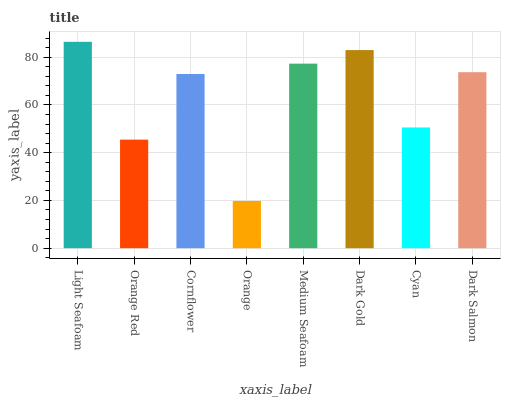Is Orange the minimum?
Answer yes or no. Yes. Is Light Seafoam the maximum?
Answer yes or no. Yes. Is Orange Red the minimum?
Answer yes or no. No. Is Orange Red the maximum?
Answer yes or no. No. Is Light Seafoam greater than Orange Red?
Answer yes or no. Yes. Is Orange Red less than Light Seafoam?
Answer yes or no. Yes. Is Orange Red greater than Light Seafoam?
Answer yes or no. No. Is Light Seafoam less than Orange Red?
Answer yes or no. No. Is Dark Salmon the high median?
Answer yes or no. Yes. Is Cornflower the low median?
Answer yes or no. Yes. Is Light Seafoam the high median?
Answer yes or no. No. Is Medium Seafoam the low median?
Answer yes or no. No. 